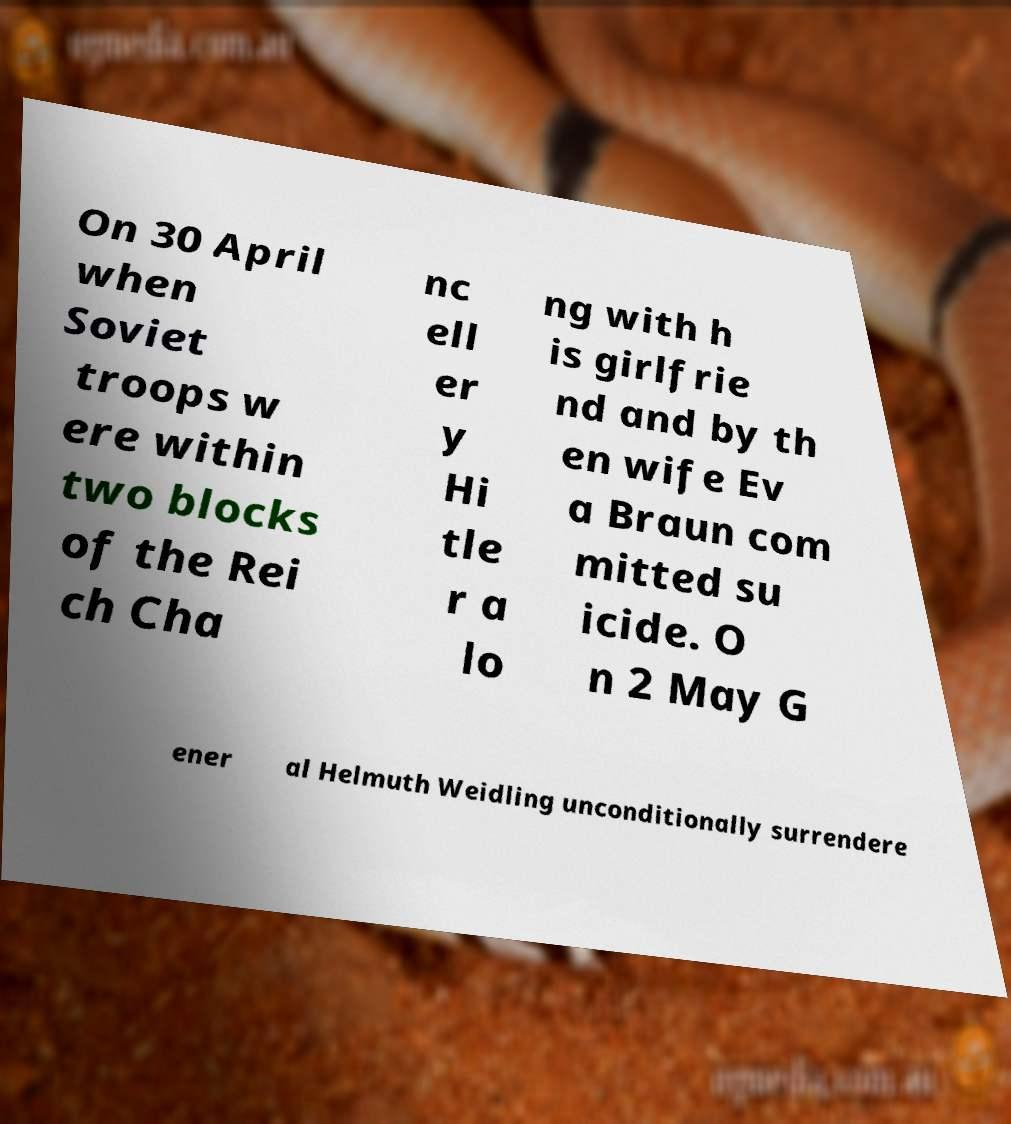Please identify and transcribe the text found in this image. On 30 April when Soviet troops w ere within two blocks of the Rei ch Cha nc ell er y Hi tle r a lo ng with h is girlfrie nd and by th en wife Ev a Braun com mitted su icide. O n 2 May G ener al Helmuth Weidling unconditionally surrendere 